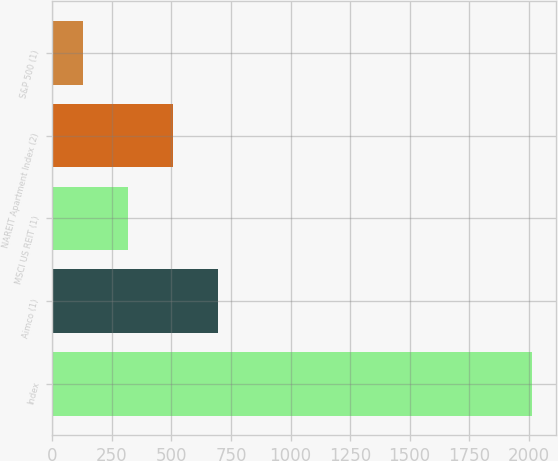Convert chart. <chart><loc_0><loc_0><loc_500><loc_500><bar_chart><fcel>Index<fcel>Aimco (1)<fcel>MSCI US REIT (1)<fcel>NAREIT Apartment Index (2)<fcel>S&P 500 (1)<nl><fcel>2016<fcel>695.14<fcel>317.75<fcel>506.45<fcel>129.05<nl></chart> 